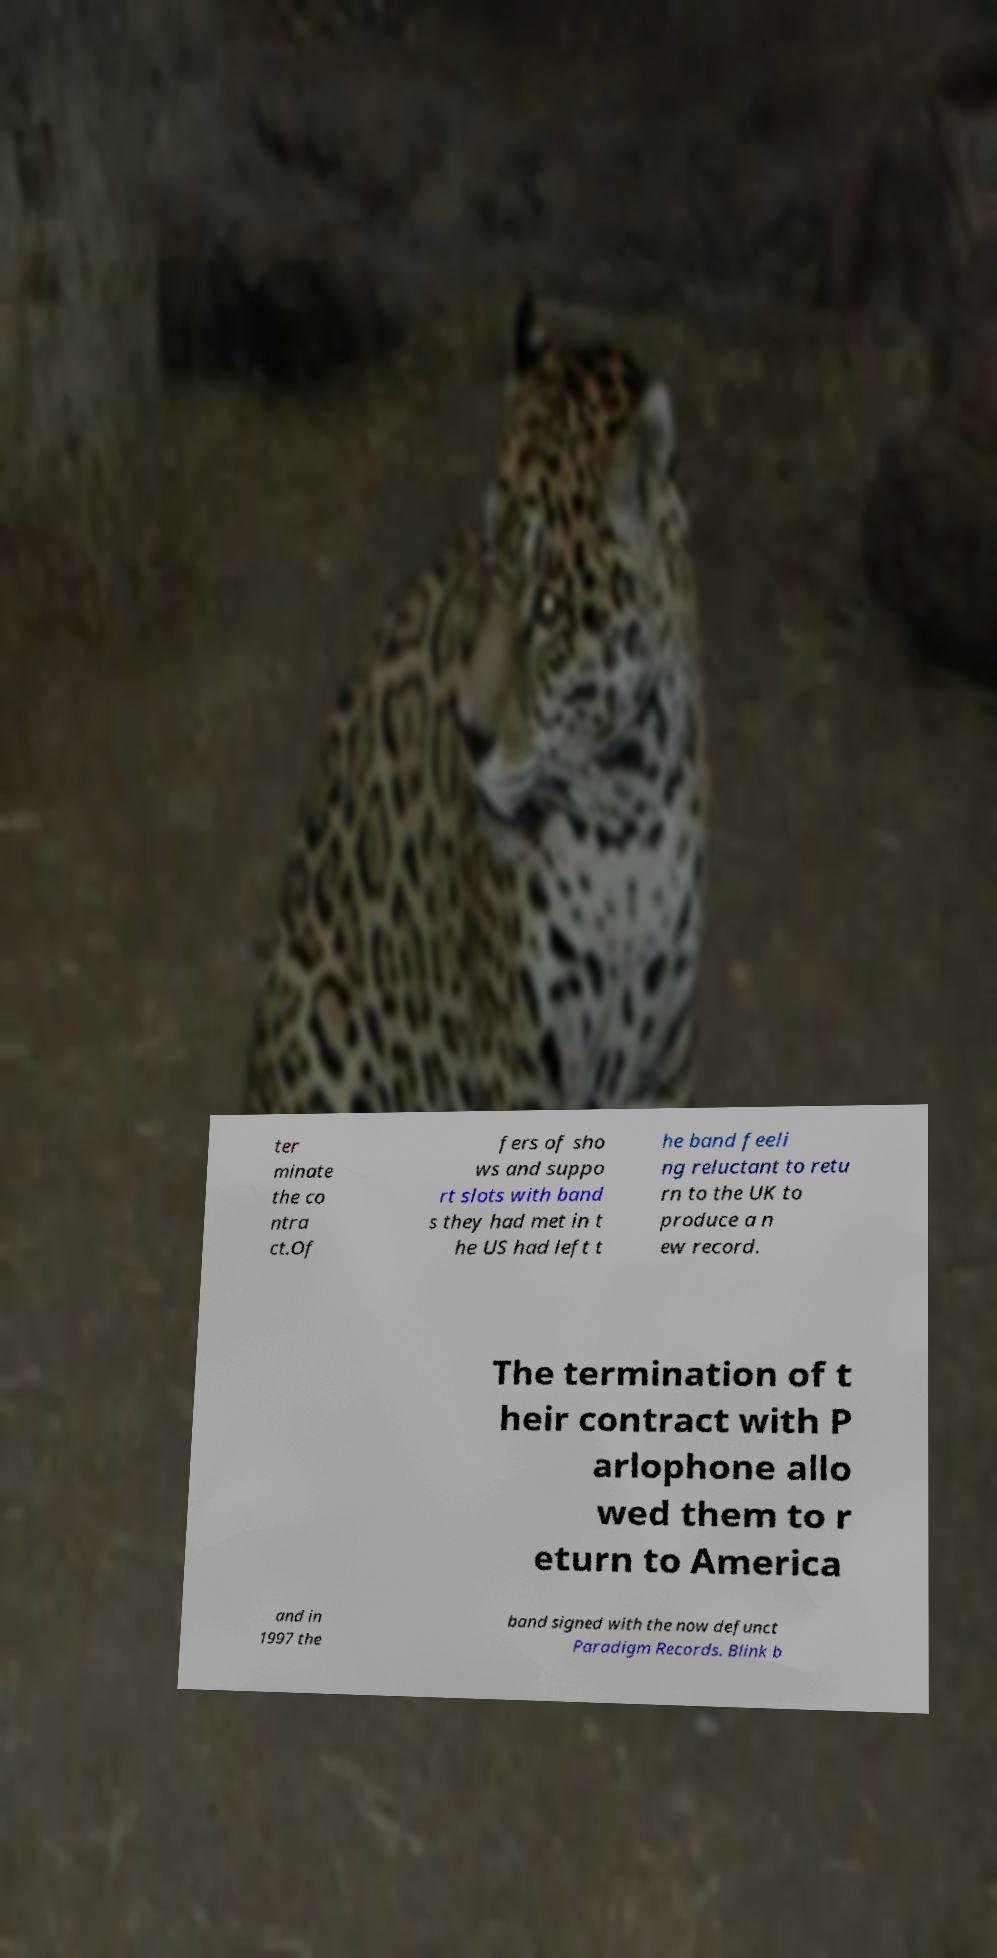Can you read and provide the text displayed in the image?This photo seems to have some interesting text. Can you extract and type it out for me? ter minate the co ntra ct.Of fers of sho ws and suppo rt slots with band s they had met in t he US had left t he band feeli ng reluctant to retu rn to the UK to produce a n ew record. The termination of t heir contract with P arlophone allo wed them to r eturn to America and in 1997 the band signed with the now defunct Paradigm Records. Blink b 